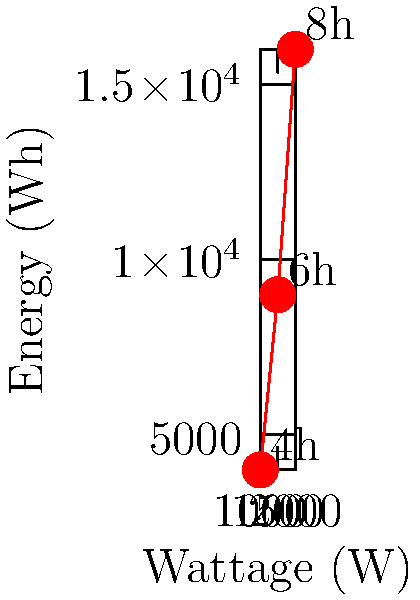For an upcoming night-time community sports tournament, you need to estimate the energy consumption of the stadium floodlights. The graph shows the relationship between wattage, hours of operation, and energy consumption. If the stadium has 20 floodlights, each rated at 1500W, and they will be used for 6 hours, what is the total energy consumption in kilowatt-hours (kWh)? To calculate the total energy consumption, we'll follow these steps:

1. Identify the wattage and hours of operation:
   - Wattage per floodlight: 1500W
   - Hours of operation: 6 hours
   - Number of floodlights: 20

2. Calculate the energy consumption for one floodlight:
   - Energy = Power × Time
   - Energy = 1500W × 6 hours = 9000 Wh

3. Calculate the total energy consumption for all floodlights:
   - Total Energy = Energy per floodlight × Number of floodlights
   - Total Energy = 9000 Wh × 20 = 180,000 Wh

4. Convert watt-hours (Wh) to kilowatt-hours (kWh):
   - 1 kWh = 1000 Wh
   - Total Energy in kWh = 180,000 Wh ÷ 1000 = 180 kWh

Therefore, the total energy consumption for 20 floodlights, each rated at 1500W and operating for 6 hours, is 180 kWh.
Answer: 180 kWh 